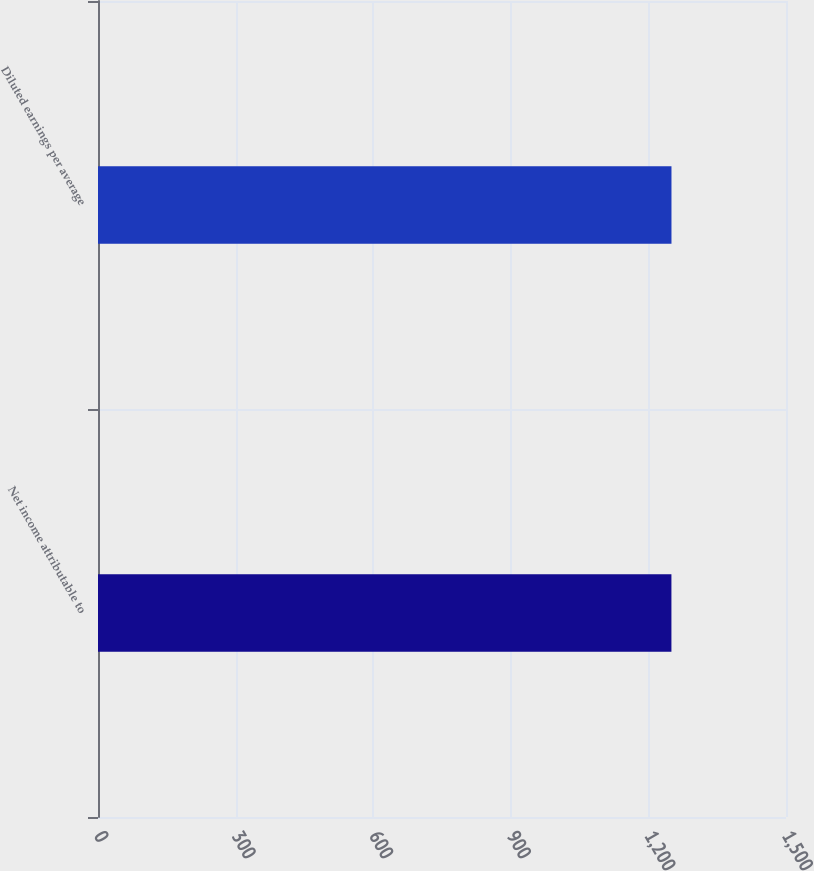Convert chart. <chart><loc_0><loc_0><loc_500><loc_500><bar_chart><fcel>Net income attributable to<fcel>Diluted earnings per average<nl><fcel>1250.2<fcel>1250.3<nl></chart> 